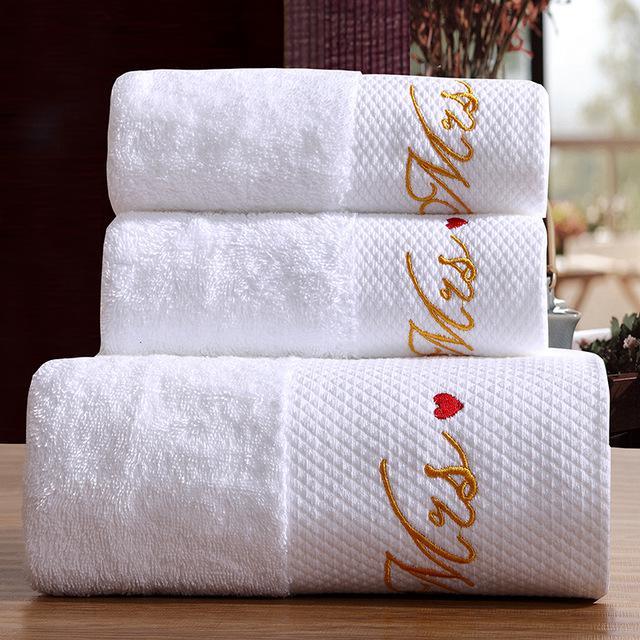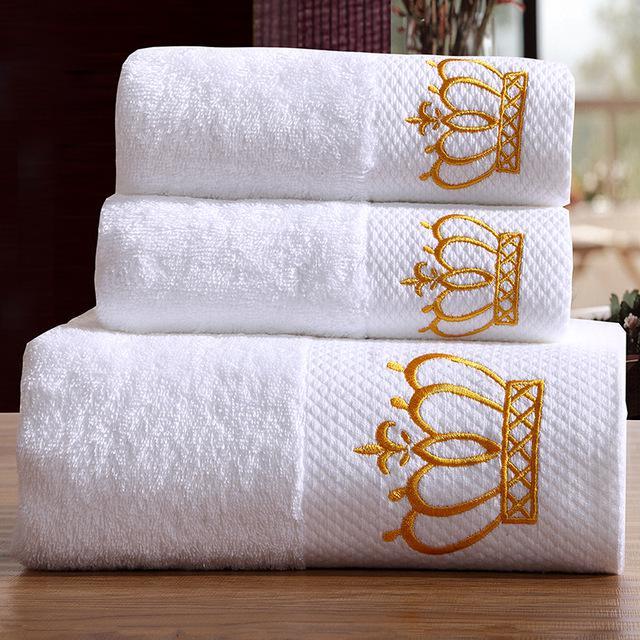The first image is the image on the left, the second image is the image on the right. Considering the images on both sides, is "Both images contain a stack of three white towels with embroidery on the bottom." valid? Answer yes or no. Yes. 